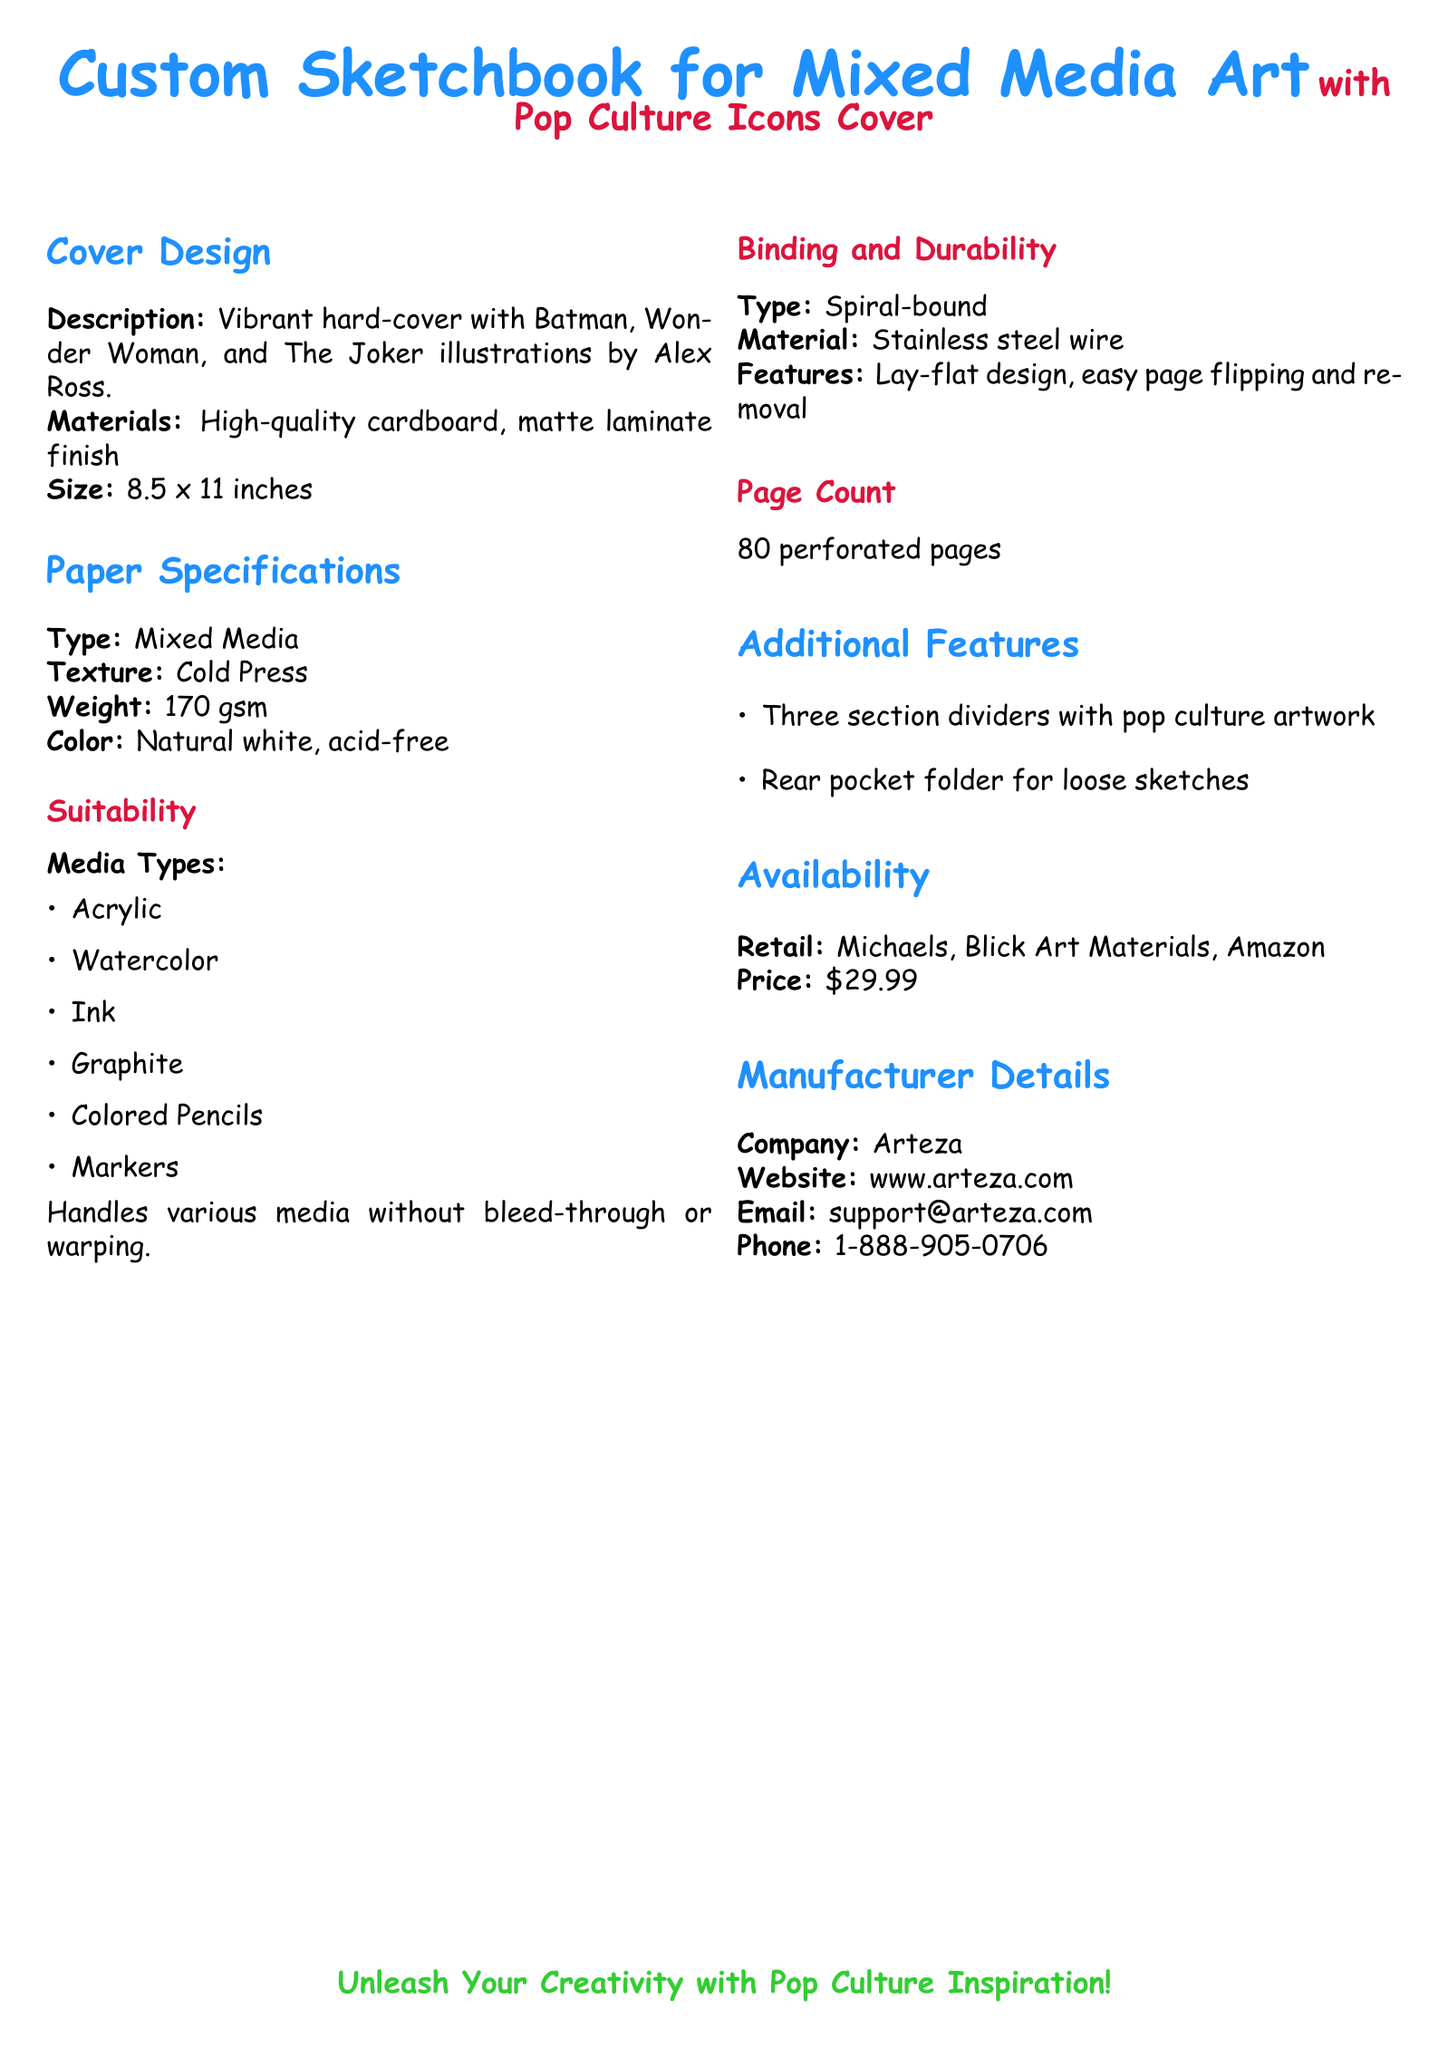What is the size of the sketchbook? The size of the sketchbook is specified in the document, which is 8.5 x 11 inches.
Answer: 8.5 x 11 inches What type of binding does the sketchbook have? The type of binding is indicated as spiral-bound in the specifications.
Answer: Spiral-bound How many pages does the sketchbook contain? The document states the page count as 80 perforated pages.
Answer: 80 pages Which media types are suitable for the sketchbook? The document lists several media types that the sketchbook can handle without bleed-through.
Answer: Acrylic, Watercolor, Ink, Graphite, Colored Pencils, Markers What is the price of the sketchbook? The price is explicitly mentioned in the availability section of the document.
Answer: $29.99 Who is the manufacturer of the sketchbook? The company name is provided under manufacturer details in the document.
Answer: Arteza What is the paper weight? The weight of the paper is clearly specified in the paper specifications section.
Answer: 170 gsm What color is the paper? The document states the color of the paper is natural white and acid-free.
Answer: Natural white, acid-free What additional features are included with the sketchbook? The additional features of the sketchbook are listed, including section dividers and a pocket folder.
Answer: Three section dividers, rear pocket folder 